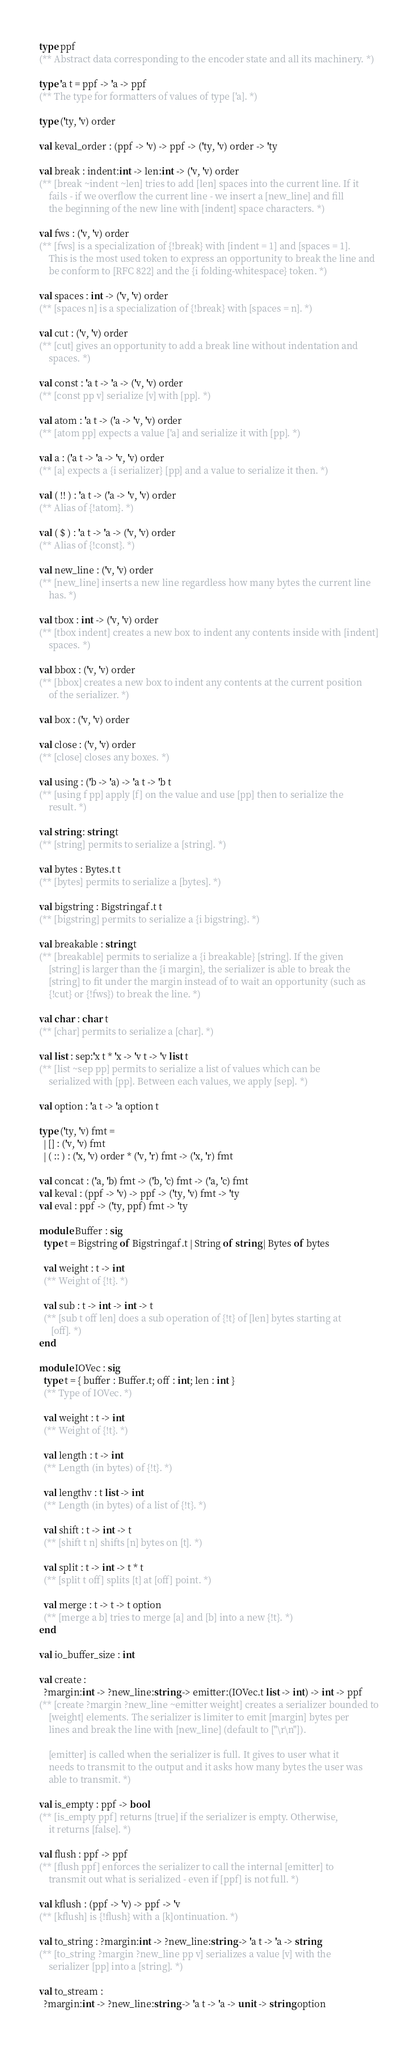<code> <loc_0><loc_0><loc_500><loc_500><_OCaml_>type ppf
(** Abstract data corresponding to the encoder state and all its machinery. *)

type 'a t = ppf -> 'a -> ppf
(** The type for formatters of values of type ['a]. *)

type ('ty, 'v) order

val keval_order : (ppf -> 'v) -> ppf -> ('ty, 'v) order -> 'ty

val break : indent:int -> len:int -> ('v, 'v) order
(** [break ~indent ~len] tries to add [len] spaces into the current line. If it
    fails - if we overflow the current line - we insert a [new_line] and fill
    the beginning of the new line with [indent] space characters. *)

val fws : ('v, 'v) order
(** [fws] is a specialization of {!break} with [indent = 1] and [spaces = 1].
    This is the most used token to express an opportunity to break the line and
    be conform to [RFC 822] and the {i folding-whitespace} token. *)

val spaces : int -> ('v, 'v) order
(** [spaces n] is a specialization of {!break} with [spaces = n]. *)

val cut : ('v, 'v) order
(** [cut] gives an opportunity to add a break line without indentation and
    spaces. *)

val const : 'a t -> 'a -> ('v, 'v) order
(** [const pp v] serialize [v] with [pp]. *)

val atom : 'a t -> ('a -> 'v, 'v) order
(** [atom pp] expects a value ['a] and serialize it with [pp]. *)

val a : ('a t -> 'a -> 'v, 'v) order
(** [a] expects a {i serializer} [pp] and a value to serialize it then. *)

val ( !! ) : 'a t -> ('a -> 'v, 'v) order
(** Alias of {!atom}. *)

val ( $ ) : 'a t -> 'a -> ('v, 'v) order
(** Alias of {!const}. *)

val new_line : ('v, 'v) order
(** [new_line] inserts a new line regardless how many bytes the current line
    has. *)

val tbox : int -> ('v, 'v) order
(** [tbox indent] creates a new box to indent any contents inside with [indent]
    spaces. *)

val bbox : ('v, 'v) order
(** [bbox] creates a new box to indent any contents at the current position
    of the serializer. *)

val box : ('v, 'v) order

val close : ('v, 'v) order
(** [close] closes any boxes. *)

val using : ('b -> 'a) -> 'a t -> 'b t
(** [using f pp] apply [f] on the value and use [pp] then to serialize the
    result. *)

val string : string t
(** [string] permits to serialize a [string]. *)

val bytes : Bytes.t t
(** [bytes] permits to serialize a [bytes]. *)

val bigstring : Bigstringaf.t t
(** [bigstring] permits to serialize a {i bigstring}. *)

val breakable : string t
(** [breakable] permits to serialize a {i breakable} [string]. If the given
    [string] is larger than the {i margin}, the serializer is able to break the
    [string] to fit under the margin instead of to wait an opportunity (such as
    {!cut} or {!fws}) to break the line. *)

val char : char t
(** [char] permits to serialize a [char]. *)

val list : sep:'x t * 'x -> 'v t -> 'v list t
(** [list ~sep pp] permits to serialize a list of values which can be
    serialized with [pp]. Between each values, we apply [sep]. *)

val option : 'a t -> 'a option t

type ('ty, 'v) fmt =
  | [] : ('v, 'v) fmt
  | ( :: ) : ('x, 'v) order * ('v, 'r) fmt -> ('x, 'r) fmt

val concat : ('a, 'b) fmt -> ('b, 'c) fmt -> ('a, 'c) fmt
val keval : (ppf -> 'v) -> ppf -> ('ty, 'v) fmt -> 'ty
val eval : ppf -> ('ty, ppf) fmt -> 'ty

module Buffer : sig
  type t = Bigstring of Bigstringaf.t | String of string | Bytes of bytes

  val weight : t -> int
  (** Weight of {!t}. *)

  val sub : t -> int -> int -> t
  (** [sub t off len] does a sub operation of {!t} of [len] bytes starting at
     [off]. *)
end

module IOVec : sig
  type t = { buffer : Buffer.t; off : int; len : int }
  (** Type of IOVec. *)

  val weight : t -> int
  (** Weight of {!t}. *)

  val length : t -> int
  (** Length (in bytes) of {!t}. *)

  val lengthv : t list -> int
  (** Length (in bytes) of a list of {!t}. *)

  val shift : t -> int -> t
  (** [shift t n] shifts [n] bytes on [t]. *)

  val split : t -> int -> t * t
  (** [split t off] splits [t] at [off] point. *)

  val merge : t -> t -> t option
  (** [merge a b] tries to merge [a] and [b] into a new {!t}. *)
end

val io_buffer_size : int

val create :
  ?margin:int -> ?new_line:string -> emitter:(IOVec.t list -> int) -> int -> ppf
(** [create ?margin ?new_line ~emitter weight] creates a serializer bounded to
    [weight] elements. The serializer is limiter to emit [margin] bytes per
    lines and break the line with [new_line] (default to ["\r\n"]).

    [emitter] is called when the serializer is full. It gives to user what it
    needs to transmit to the output and it asks how many bytes the user was
    able to transmit. *)

val is_empty : ppf -> bool
(** [is_empty ppf] returns [true] if the serializer is empty. Otherwise,
    it returns [false]. *)

val flush : ppf -> ppf
(** [flush ppf] enforces the serializer to call the internal [emitter] to
    transmit out what is serialized - even if [ppf] is not full. *)

val kflush : (ppf -> 'v) -> ppf -> 'v
(** [kflush] is {!flush} with a [k]ontinuation. *)

val to_string : ?margin:int -> ?new_line:string -> 'a t -> 'a -> string
(** [to_string ?margin ?new_line pp v] serializes a value [v] with the
    serializer [pp] into a [string]. *)

val to_stream :
  ?margin:int -> ?new_line:string -> 'a t -> 'a -> unit -> string option</code> 